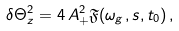Convert formula to latex. <formula><loc_0><loc_0><loc_500><loc_500>\delta \Theta _ { z } ^ { 2 } = 4 \, A _ { + } ^ { 2 } \mathfrak { F } ( \omega _ { g } , s , t _ { 0 } ) \, ,</formula> 